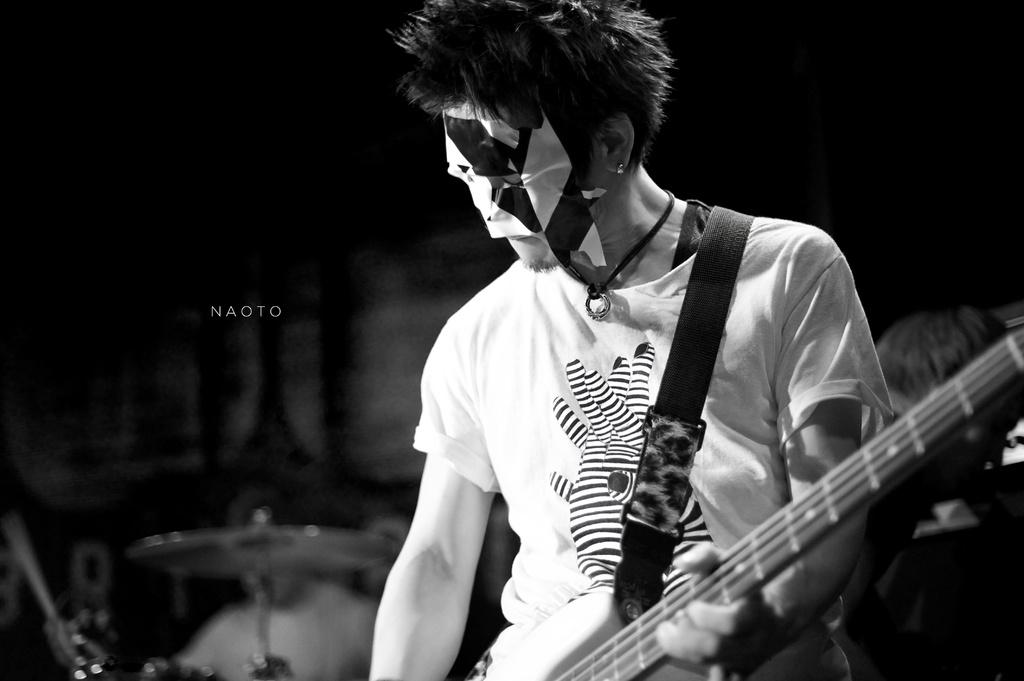What is the color scheme of the image? The image is black and white. Who is present in the image? There is a man in the image. What is the man doing in the image? The man is standing in the image. What is the man wearing in the image? The man is wearing a guitar and a mask on his face. What else can be seen in the background of the image? There is other musical equipment in the background of the image. What type of knot is tied around the man's neck in the image? There is no knot tied around the man's neck in the image. What is the value of the guitar in the image? The value of the guitar cannot be determined from the image alone. 